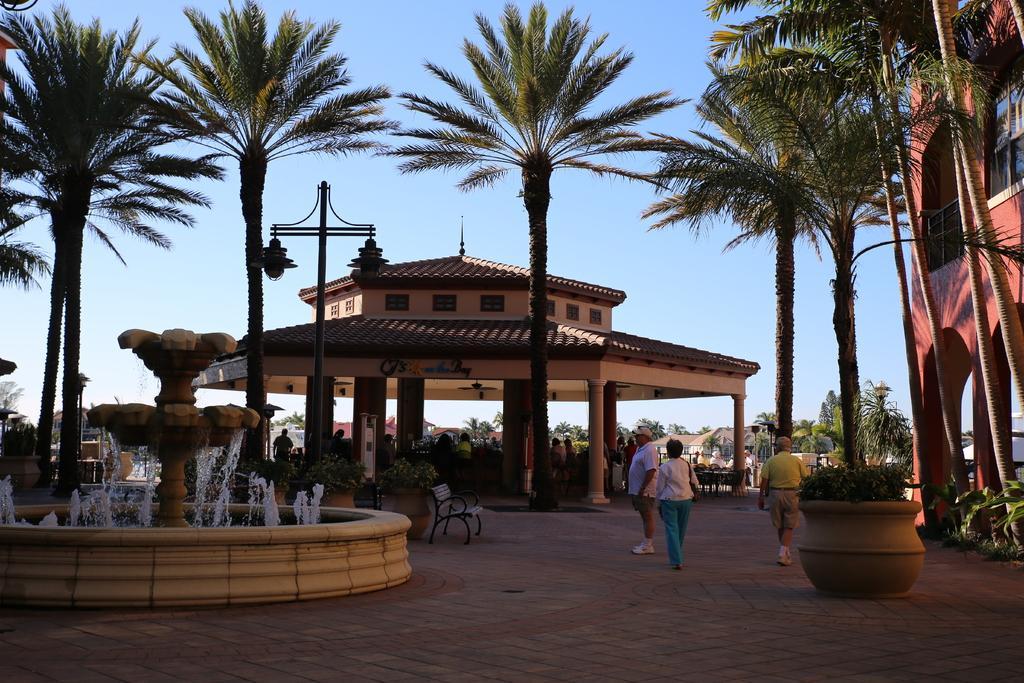How would you summarize this image in a sentence or two? This picture shows few trees and we see building and a water fountain and we see a bench and few people walking and few are standing and we see pole lights and a blue sky and few pots with plants. 